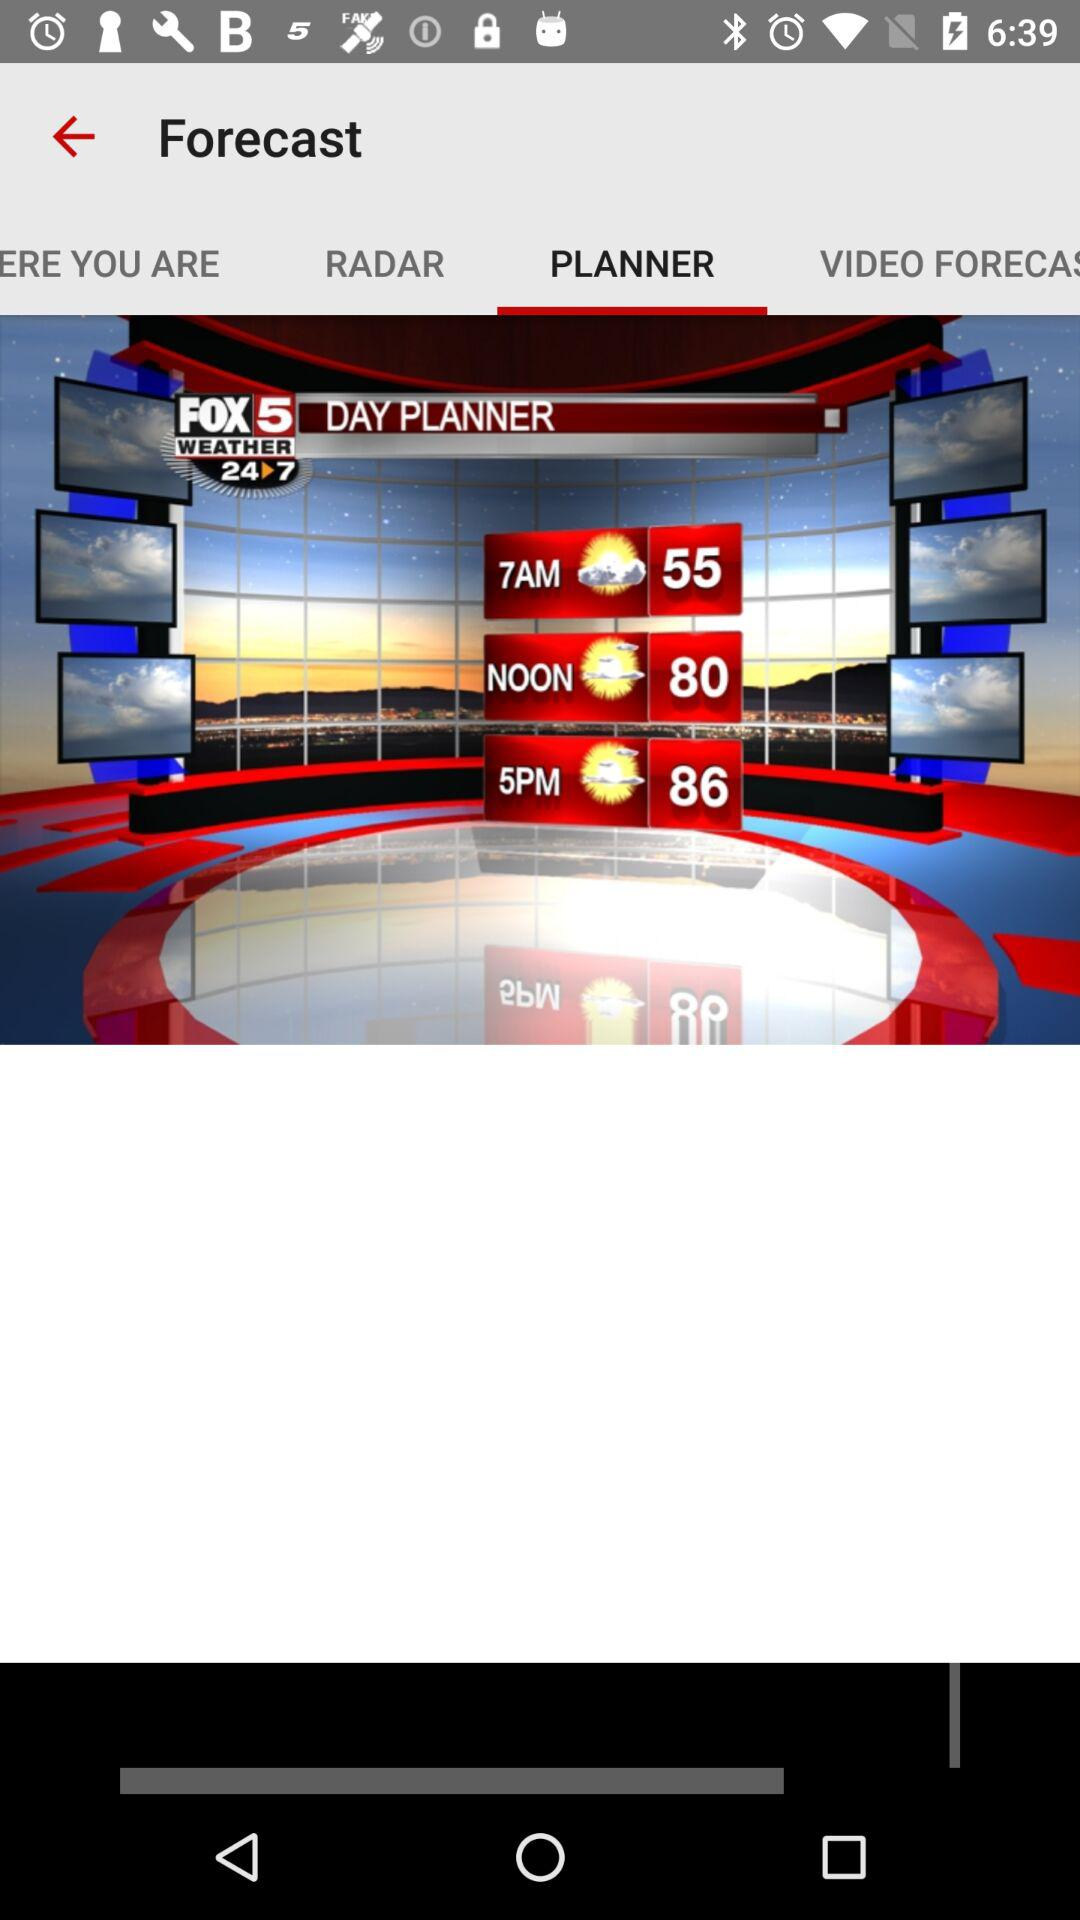Which tab is selected? The selected tab is "PLANNER". 